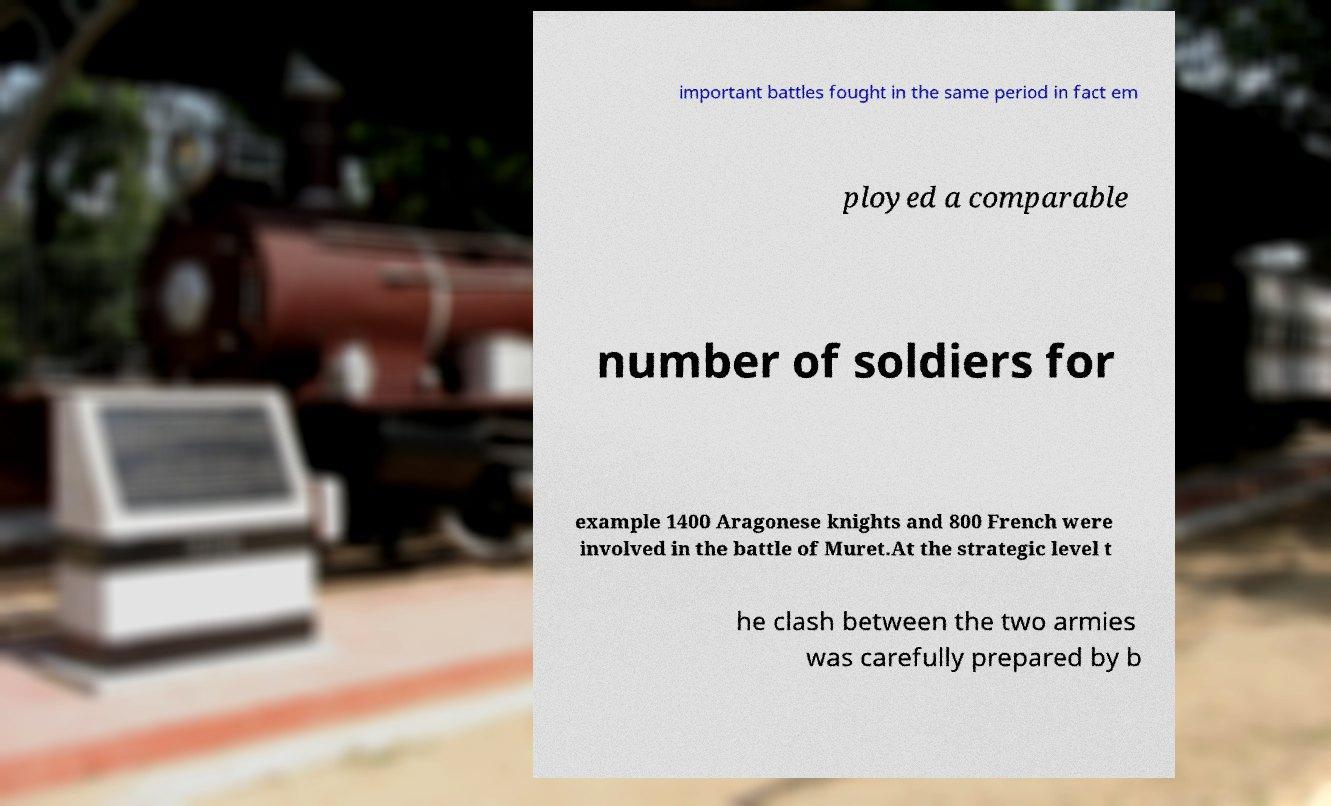I need the written content from this picture converted into text. Can you do that? important battles fought in the same period in fact em ployed a comparable number of soldiers for example 1400 Aragonese knights and 800 French were involved in the battle of Muret.At the strategic level t he clash between the two armies was carefully prepared by b 